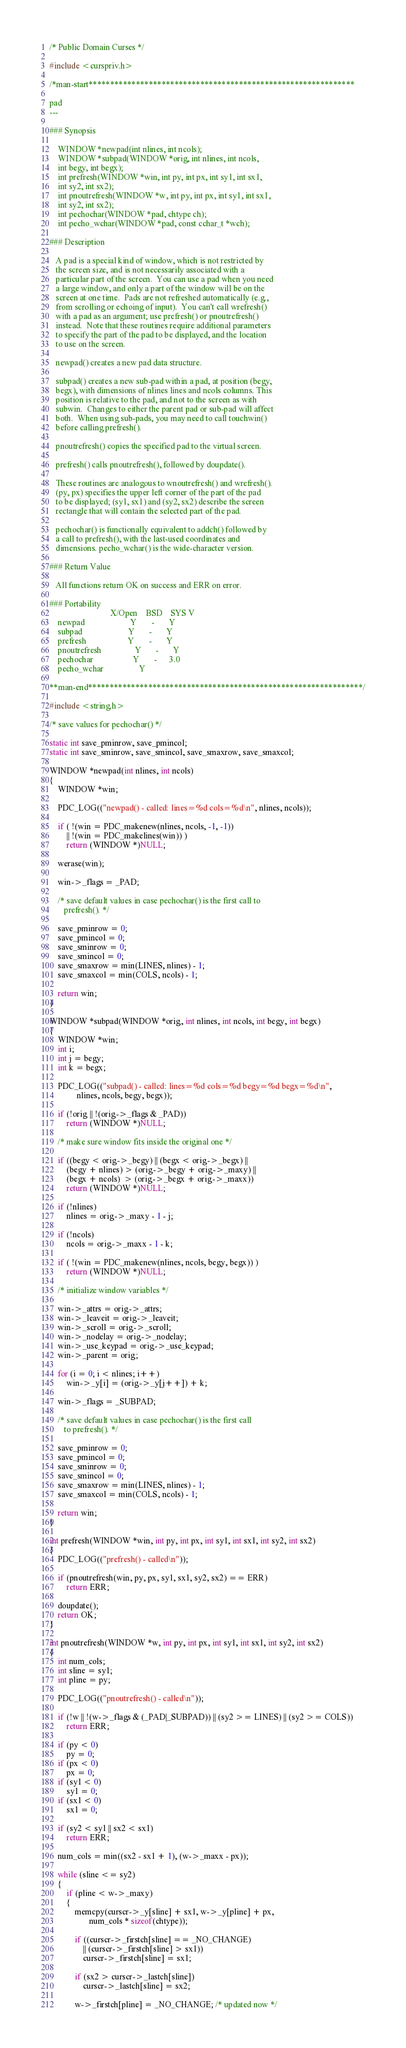Convert code to text. <code><loc_0><loc_0><loc_500><loc_500><_C_>/* Public Domain Curses */

#include <curspriv.h>

/*man-start**************************************************************

pad
---

### Synopsis

    WINDOW *newpad(int nlines, int ncols);
    WINDOW *subpad(WINDOW *orig, int nlines, int ncols,
    int begy, int begx);
    int prefresh(WINDOW *win, int py, int px, int sy1, int sx1,
    int sy2, int sx2);
    int pnoutrefresh(WINDOW *w, int py, int px, int sy1, int sx1,
    int sy2, int sx2);
    int pechochar(WINDOW *pad, chtype ch);
    int pecho_wchar(WINDOW *pad, const cchar_t *wch);

### Description

   A pad is a special kind of window, which is not restricted by
   the screen size, and is not necessarily associated with a
   particular part of the screen.  You can use a pad when you need
   a large window, and only a part of the window will be on the
   screen at one time.  Pads are not refreshed automatically (e.g.,
   from scrolling or echoing of input).  You can't call wrefresh()
   with a pad as an argument; use prefresh() or pnoutrefresh()
   instead.  Note that these routines require additional parameters
   to specify the part of the pad to be displayed, and the location
   to use on the screen.

   newpad() creates a new pad data structure.

   subpad() creates a new sub-pad within a pad, at position (begy,
   begx), with dimensions of nlines lines and ncols columns. This
   position is relative to the pad, and not to the screen as with
   subwin.  Changes to either the parent pad or sub-pad will affect
   both.  When using sub-pads, you may need to call touchwin()
   before calling prefresh().

   pnoutrefresh() copies the specified pad to the virtual screen.

   prefresh() calls pnoutrefresh(), followed by doupdate().

   These routines are analogous to wnoutrefresh() and wrefresh().
   (py, px) specifies the upper left corner of the part of the pad
   to be displayed; (sy1, sx1) and (sy2, sx2) describe the screen
   rectangle that will contain the selected part of the pad.

   pechochar() is functionally equivalent to addch() followed by
   a call to prefresh(), with the last-used coordinates and
   dimensions. pecho_wchar() is the wide-character version.

### Return Value

   All functions return OK on success and ERR on error.

### Portability
                             X/Open    BSD    SYS V
    newpad                      Y       -       Y
    subpad                      Y       -       Y
    prefresh                    Y       -       Y
    pnoutrefresh                Y       -       Y
    pechochar                   Y       -      3.0
    pecho_wchar                 Y

**man-end****************************************************************/

#include <string.h>

/* save values for pechochar() */

static int save_pminrow, save_pmincol;
static int save_sminrow, save_smincol, save_smaxrow, save_smaxcol;

WINDOW *newpad(int nlines, int ncols)
{
    WINDOW *win;

    PDC_LOG(("newpad() - called: lines=%d cols=%d\n", nlines, ncols));

    if ( !(win = PDC_makenew(nlines, ncols, -1, -1))
        || !(win = PDC_makelines(win)) )
        return (WINDOW *)NULL;

    werase(win);

    win->_flags = _PAD;

    /* save default values in case pechochar() is the first call to 
       prefresh(). */

    save_pminrow = 0;
    save_pmincol = 0;
    save_sminrow = 0;
    save_smincol = 0;
    save_smaxrow = min(LINES, nlines) - 1;
    save_smaxcol = min(COLS, ncols) - 1;

    return win;
}

WINDOW *subpad(WINDOW *orig, int nlines, int ncols, int begy, int begx)
{
    WINDOW *win;
    int i;
    int j = begy;
    int k = begx;

    PDC_LOG(("subpad() - called: lines=%d cols=%d begy=%d begx=%d\n",
             nlines, ncols, begy, begx));

    if (!orig || !(orig->_flags & _PAD))
        return (WINDOW *)NULL;

    /* make sure window fits inside the original one */

    if ((begy < orig->_begy) || (begx < orig->_begx) ||
        (begy + nlines) > (orig->_begy + orig->_maxy) ||
        (begx + ncols)  > (orig->_begx + orig->_maxx))
        return (WINDOW *)NULL;

    if (!nlines) 
        nlines = orig->_maxy - 1 - j;

    if (!ncols) 
        ncols = orig->_maxx - 1 - k;

    if ( !(win = PDC_makenew(nlines, ncols, begy, begx)) )
        return (WINDOW *)NULL;

    /* initialize window variables */

    win->_attrs = orig->_attrs;
    win->_leaveit = orig->_leaveit;
    win->_scroll = orig->_scroll;
    win->_nodelay = orig->_nodelay;
    win->_use_keypad = orig->_use_keypad;
    win->_parent = orig;

    for (i = 0; i < nlines; i++)
        win->_y[i] = (orig->_y[j++]) + k;

    win->_flags = _SUBPAD;

    /* save default values in case pechochar() is the first call
       to prefresh(). */

    save_pminrow = 0;
    save_pmincol = 0;
    save_sminrow = 0;
    save_smincol = 0;
    save_smaxrow = min(LINES, nlines) - 1;
    save_smaxcol = min(COLS, ncols) - 1;

    return win;
}

int prefresh(WINDOW *win, int py, int px, int sy1, int sx1, int sy2, int sx2)
{
    PDC_LOG(("prefresh() - called\n"));

    if (pnoutrefresh(win, py, px, sy1, sx1, sy2, sx2) == ERR)
        return ERR;

    doupdate();
    return OK;
}

int pnoutrefresh(WINDOW *w, int py, int px, int sy1, int sx1, int sy2, int sx2)
{
    int num_cols;
    int sline = sy1;
    int pline = py;

    PDC_LOG(("pnoutrefresh() - called\n"));

    if (!w || !(w->_flags & (_PAD|_SUBPAD)) || (sy2 >= LINES) || (sy2 >= COLS))
        return ERR;

    if (py < 0)
        py = 0;
    if (px < 0)
        px = 0;
    if (sy1 < 0)
        sy1 = 0;
    if (sx1 < 0)
        sx1 = 0;

    if (sy2 < sy1 || sx2 < sx1)
        return ERR;

    num_cols = min((sx2 - sx1 + 1), (w->_maxx - px));

    while (sline <= sy2)
    {
        if (pline < w->_maxy)
        {
            memcpy(curscr->_y[sline] + sx1, w->_y[pline] + px,
                   num_cols * sizeof(chtype));

            if ((curscr->_firstch[sline] == _NO_CHANGE) 
                || (curscr->_firstch[sline] > sx1))
                curscr->_firstch[sline] = sx1;

            if (sx2 > curscr->_lastch[sline])
                curscr->_lastch[sline] = sx2;

            w->_firstch[pline] = _NO_CHANGE; /* updated now */</code> 